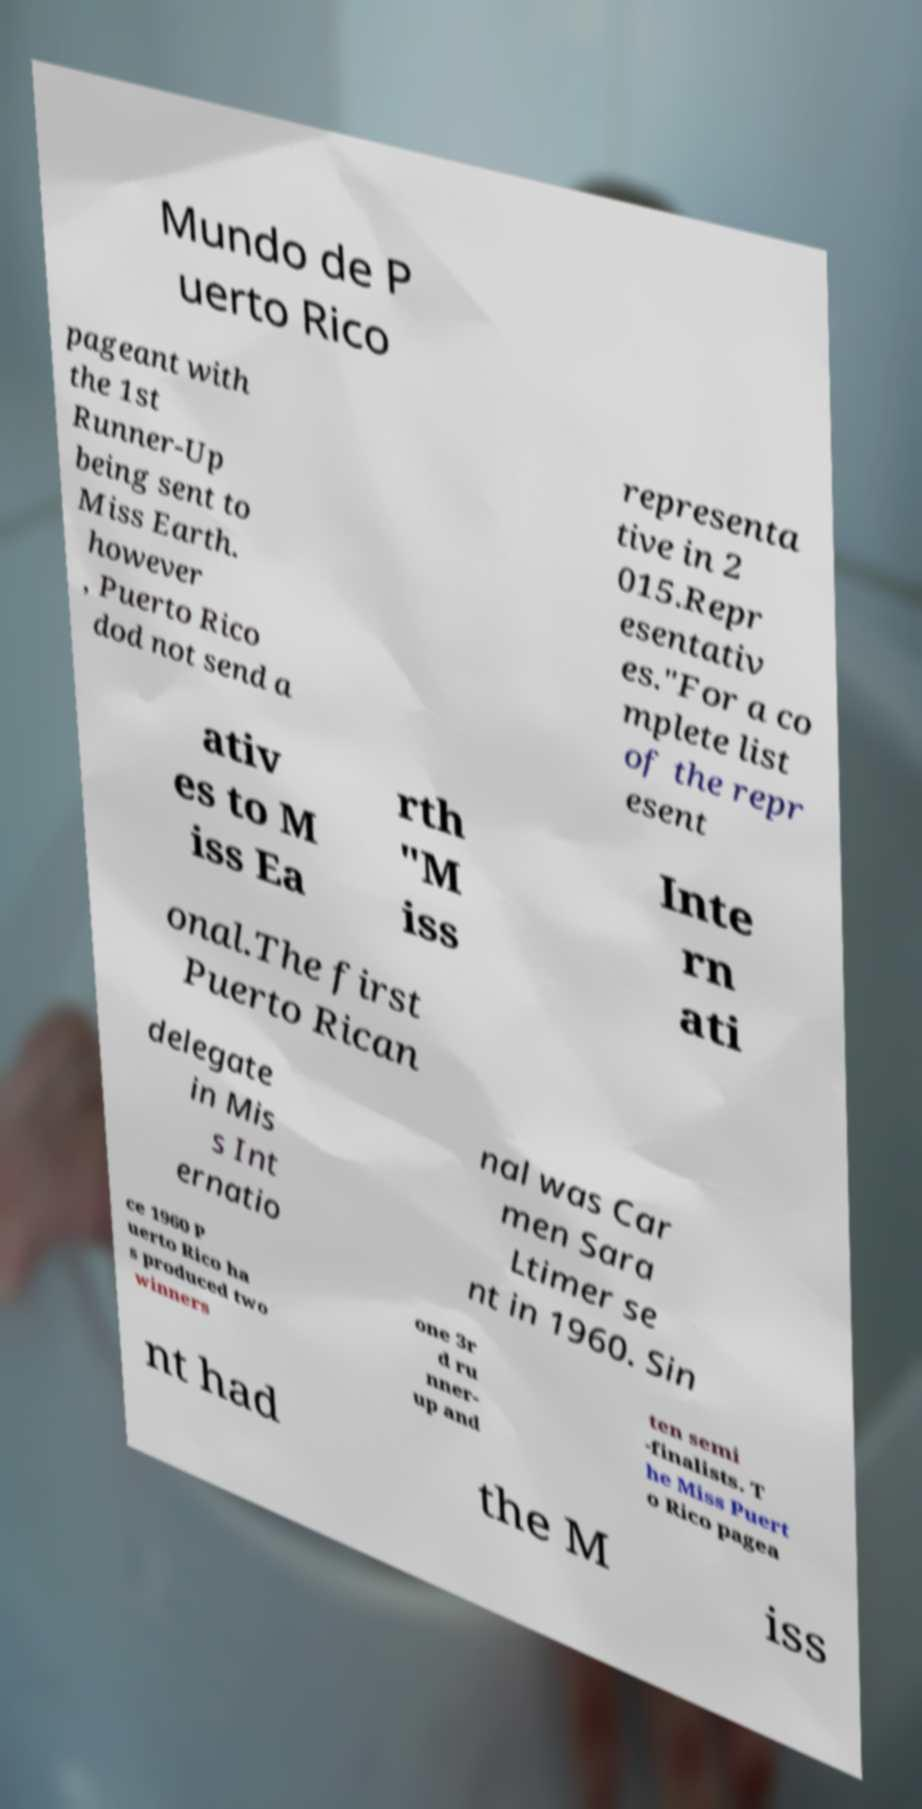Could you assist in decoding the text presented in this image and type it out clearly? Mundo de P uerto Rico pageant with the 1st Runner-Up being sent to Miss Earth. however , Puerto Rico dod not send a representa tive in 2 015.Repr esentativ es."For a co mplete list of the repr esent ativ es to M iss Ea rth "M iss Inte rn ati onal.The first Puerto Rican delegate in Mis s Int ernatio nal was Car men Sara Ltimer se nt in 1960. Sin ce 1960 P uerto Rico ha s produced two winners one 3r d ru nner- up and ten semi -finalists. T he Miss Puert o Rico pagea nt had the M iss 